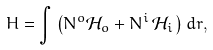Convert formula to latex. <formula><loc_0><loc_0><loc_500><loc_500>H = \int \left ( N ^ { o } \mathcal { H } _ { o } + N ^ { i } \, \mathcal { H } _ { i } \, \right ) d r ,</formula> 